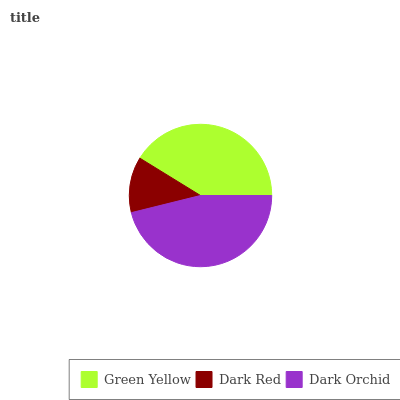Is Dark Red the minimum?
Answer yes or no. Yes. Is Dark Orchid the maximum?
Answer yes or no. Yes. Is Dark Orchid the minimum?
Answer yes or no. No. Is Dark Red the maximum?
Answer yes or no. No. Is Dark Orchid greater than Dark Red?
Answer yes or no. Yes. Is Dark Red less than Dark Orchid?
Answer yes or no. Yes. Is Dark Red greater than Dark Orchid?
Answer yes or no. No. Is Dark Orchid less than Dark Red?
Answer yes or no. No. Is Green Yellow the high median?
Answer yes or no. Yes. Is Green Yellow the low median?
Answer yes or no. Yes. Is Dark Red the high median?
Answer yes or no. No. Is Dark Orchid the low median?
Answer yes or no. No. 